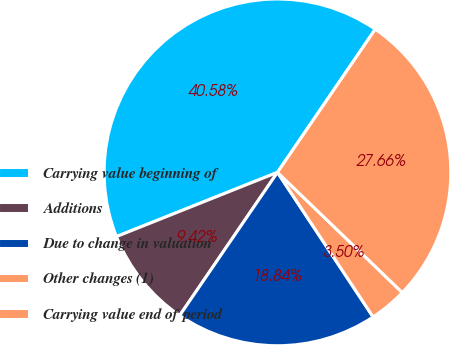<chart> <loc_0><loc_0><loc_500><loc_500><pie_chart><fcel>Carrying value beginning of<fcel>Additions<fcel>Due to change in valuation<fcel>Other changes (1)<fcel>Carrying value end of period<nl><fcel>40.58%<fcel>9.42%<fcel>18.84%<fcel>3.5%<fcel>27.66%<nl></chart> 